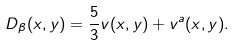Convert formula to latex. <formula><loc_0><loc_0><loc_500><loc_500>D _ { \beta } ( x , y ) = \frac { 5 } { 3 } v ( x , y ) + v ^ { a } ( x , y ) .</formula> 